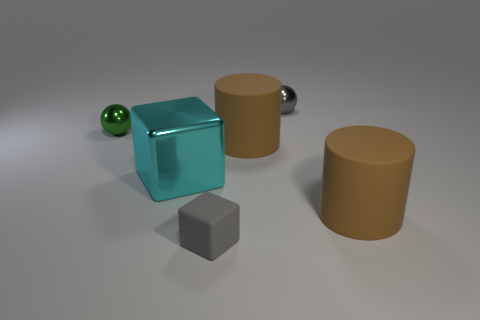Subtract 1 cylinders. How many cylinders are left? 1 Add 1 large cylinders. How many objects exist? 7 Subtract 0 blue balls. How many objects are left? 6 Subtract all cubes. How many objects are left? 4 Subtract all blue blocks. Subtract all red cylinders. How many blocks are left? 2 Subtract all purple blocks. How many gray spheres are left? 1 Subtract all big brown matte objects. Subtract all tiny balls. How many objects are left? 2 Add 2 small gray spheres. How many small gray spheres are left? 3 Add 2 large red rubber things. How many large red rubber things exist? 2 